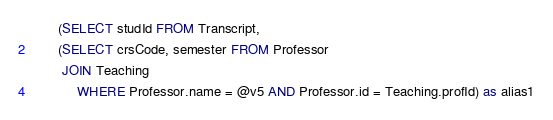Convert code to text. <code><loc_0><loc_0><loc_500><loc_500><_SQL_>	   (SELECT studId FROM Transcript,
	   (SELECT crsCode, semester FROM Professor
		JOIN Teaching
			WHERE Professor.name = @v5 AND Professor.id = Teaching.profId) as alias1</code> 